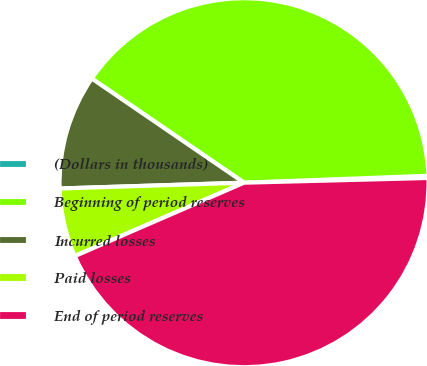Convert chart. <chart><loc_0><loc_0><loc_500><loc_500><pie_chart><fcel>(Dollars in thousands)<fcel>Beginning of period reserves<fcel>Incurred losses<fcel>Paid losses<fcel>End of period reserves<nl><fcel>0.19%<fcel>39.85%<fcel>10.05%<fcel>6.01%<fcel>43.89%<nl></chart> 